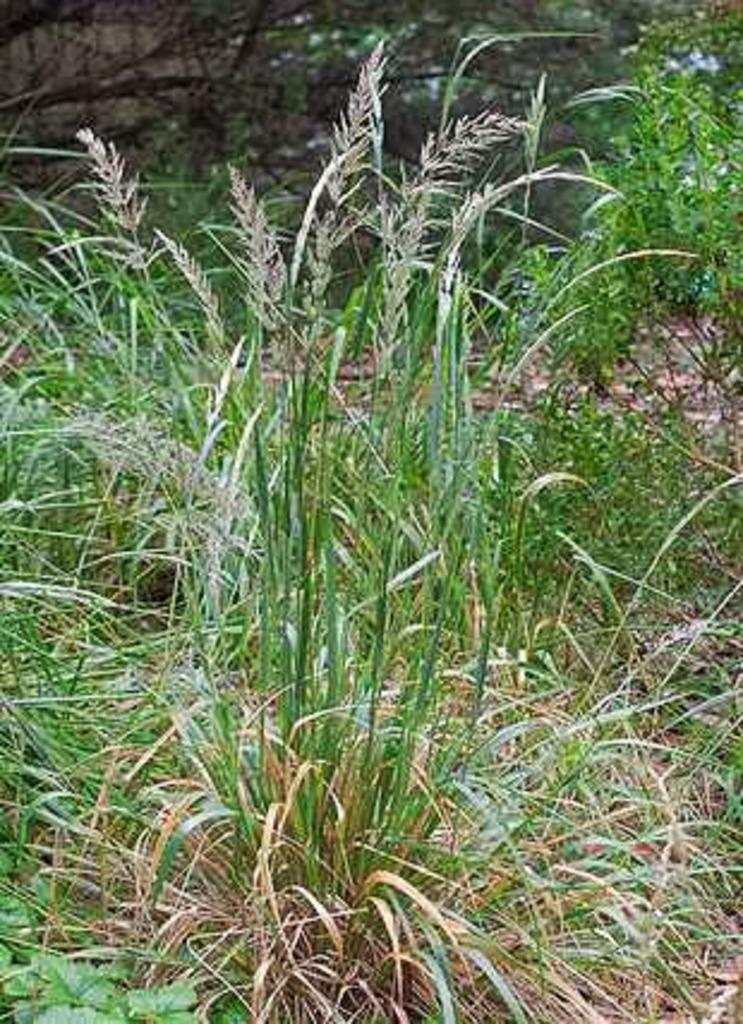Can you describe the "glass plants" mentioned in the image? Unfortunately, the term "glass plants" is ambiguous, and we cannot confidently describe them based on the provided information. What type of wound can be seen on the glass plants in the image? There is no wound present on the glass plants in the image, as the term "glass plants" is ambiguous and cannot be confidently described based on the provided information. 